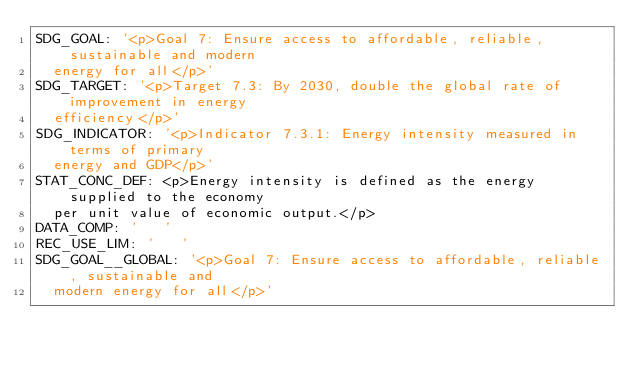Convert code to text. <code><loc_0><loc_0><loc_500><loc_500><_YAML_>SDG_GOAL: '<p>Goal 7: Ensure access to affordable, reliable, sustainable and modern
  energy for all</p>'
SDG_TARGET: '<p>Target 7.3: By 2030, double the global rate of improvement in energy
  efficiency</p>'
SDG_INDICATOR: '<p>Indicator 7.3.1: Energy intensity measured in terms of primary
  energy and GDP</p>'
STAT_CONC_DEF: <p>Energy intensity is defined as the energy supplied to the economy
  per unit value of economic output.</p>
DATA_COMP: '   '
REC_USE_LIM: '   '
SDG_GOAL__GLOBAL: '<p>Goal 7: Ensure access to affordable, reliable, sustainable and
  modern energy for all</p>'</code> 